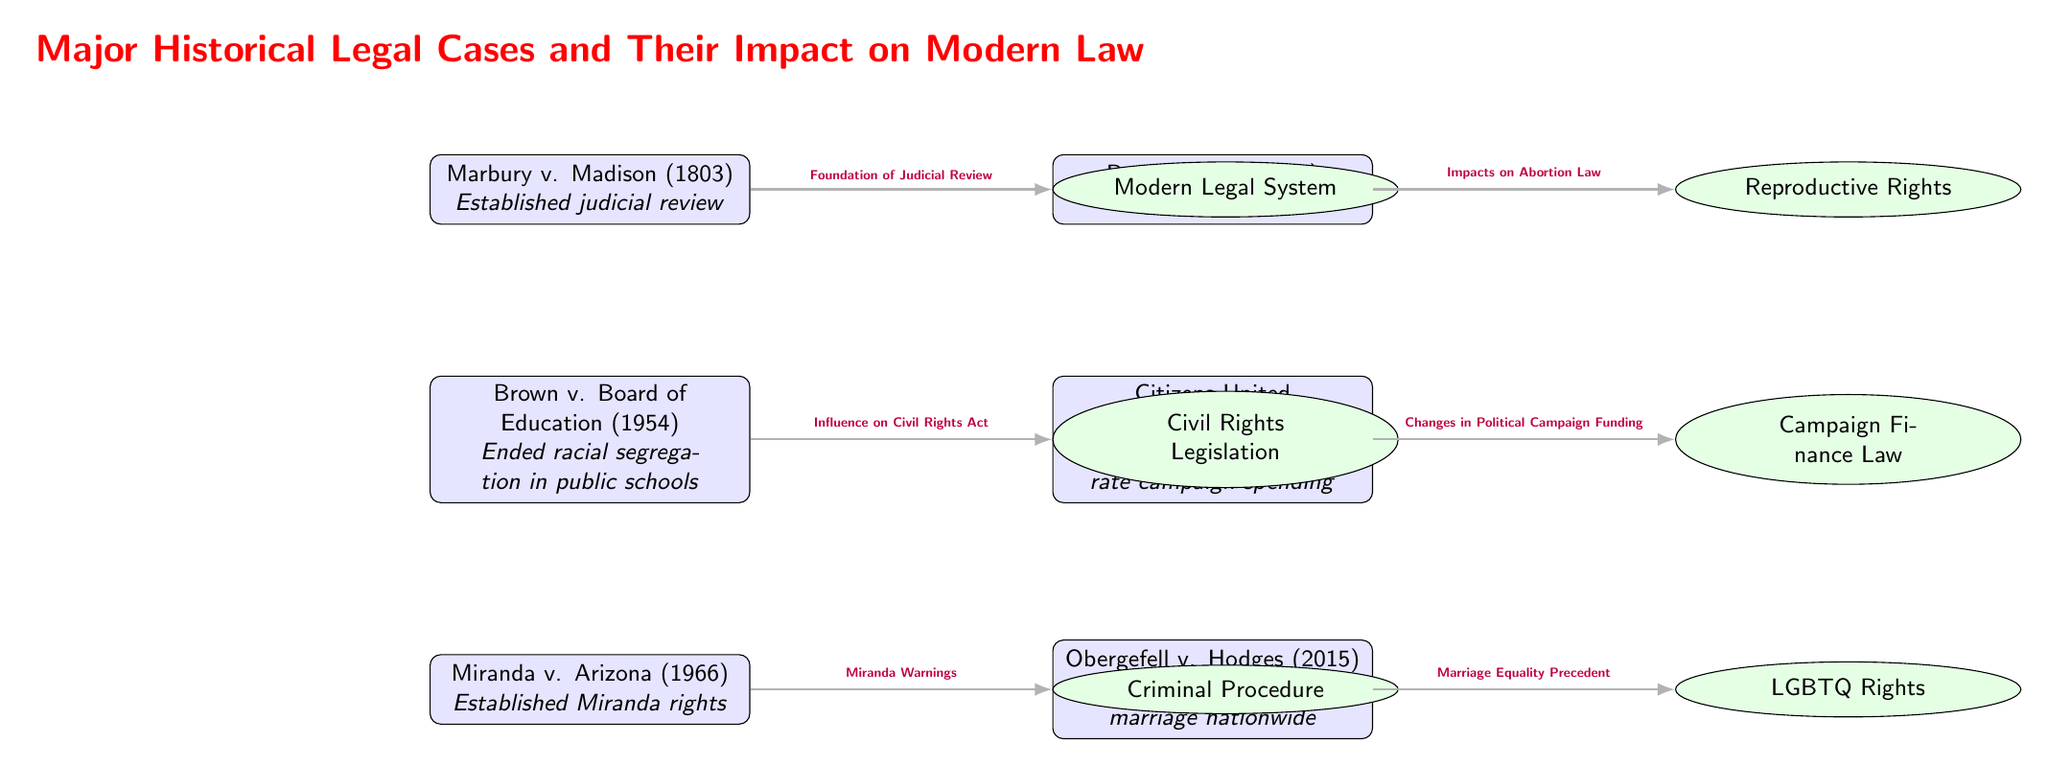What is the case that established judicial review? The diagram shows Marbury v. Madison (1803) as the case that established judicial review, indicated at the top of the diagram with its description clearly listed.
Answer: Marbury v. Madison (1803) How many major historical legal cases are shown in the diagram? By counting the nodes labeled with cases in the diagram, there are six cases listed: Marbury v. Madison, Brown v. Board of Education, Miranda v. Arizona, Roe v. Wade, Citizens United v. FEC, and Obergefell v. Hodges, which totals six.
Answer: 6 What impact did Brown v. Board of Education have? According to the diagram, the impact of Brown v. Board of Education is shown as influencing the Civil Rights Act, indicated by the edge connecting the case node to the Civil Rights Legislation impact node.
Answer: Civil Rights Legislation Which case legalized same-sex marriage nationwide? The diagram indicates that Obergefell v. Hodges (2015) is the case that legalized same-sex marriage nationwide, as specified in the description next to the node corresponding to that case.
Answer: Obergefell v. Hodges (2015) Which case is connected to changes in political campaign funding? The edge connecting Citizens United v. FEC (2010) to the impact node that indicates changes in campaign finance law shows that this case is connected to changes in political campaign funding.
Answer: Citizens United v. FEC (2010) What is the relationship between Marbury v. Madison and the modern legal system? The diagram depicts an arrow from the Marbury v. Madison case to the Modern Legal System impact node, labeled "Foundation of Judicial Review," indicating that this case laid the groundwork for the judicial system today.
Answer: Foundation of Judicial Review How many impacts are connected to the case Roe v. Wade? The diagram indicates one impact connected to the case Roe v. Wade, which is linked to the Reproductive Rights impact node by an edge labeled "Impacts on Abortion Law."
Answer: 1 What impact did Miranda v. Arizona establish? The diagram establishes that Miranda v. Arizona had an impact on Criminal Procedure, as shown by the edge leading from the case node to the Criminal Procedure impact node labeled "Miranda Warnings."
Answer: Criminal Procedure What type of rights did the case Citizens United v. FEC impact? According to the diagram, Citizens United v. FEC is related to Campaign Finance Law, which is depicted as the impact of this case in the diagram.
Answer: Campaign Finance Law 